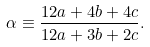Convert formula to latex. <formula><loc_0><loc_0><loc_500><loc_500>\alpha \equiv \frac { 1 2 a + 4 b + 4 c } { 1 2 a + 3 b + 2 c } .</formula> 